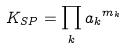Convert formula to latex. <formula><loc_0><loc_0><loc_500><loc_500>K _ { S P } = \prod _ { k } { a _ { k } } ^ { m _ { k } }</formula> 